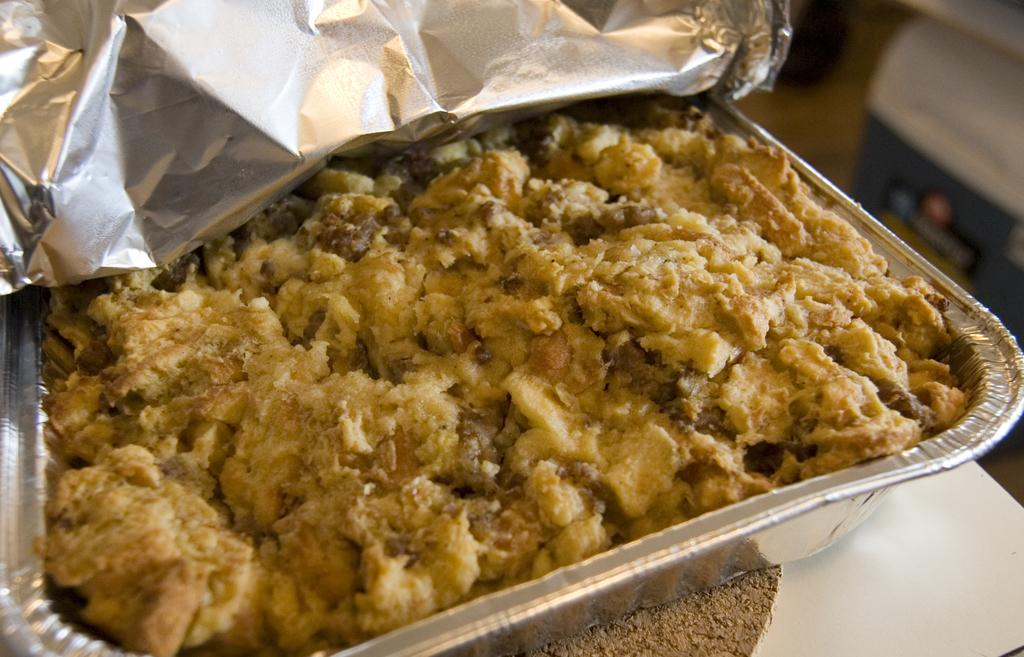What is present in the image? There is food in the image. How is the food stored or contained? The food is placed in a container. Where is the container located? The container is kept on a surface. What type of design can be seen on the fairies' wings in the image? There are no fairies or wings present in the image; it only features food in a container on a surface. 